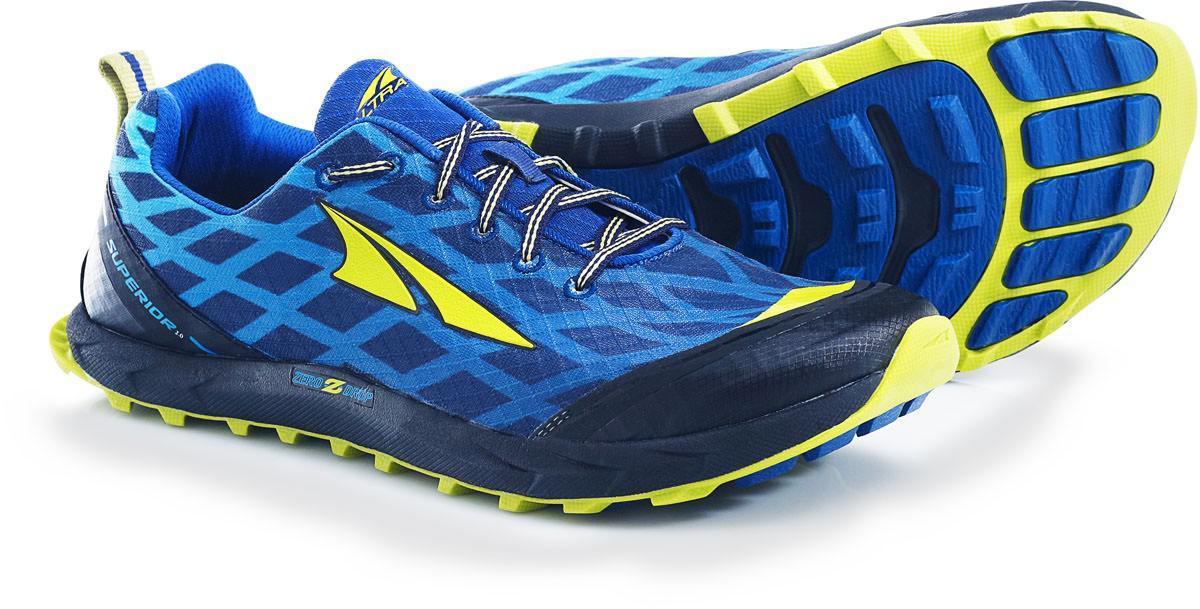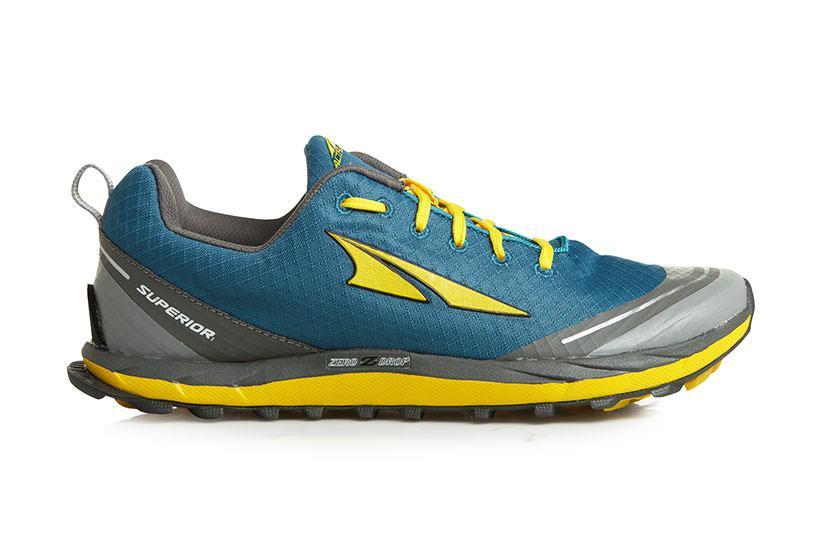The first image is the image on the left, the second image is the image on the right. Analyze the images presented: Is the assertion "One of the three sneakers has yellow shoe laces and it is not laying on it's side." valid? Answer yes or no. Yes. The first image is the image on the left, the second image is the image on the right. Given the left and right images, does the statement "In at least one photo there is a teal shoe with gray trimming and yellow laces facing right." hold true? Answer yes or no. Yes. 